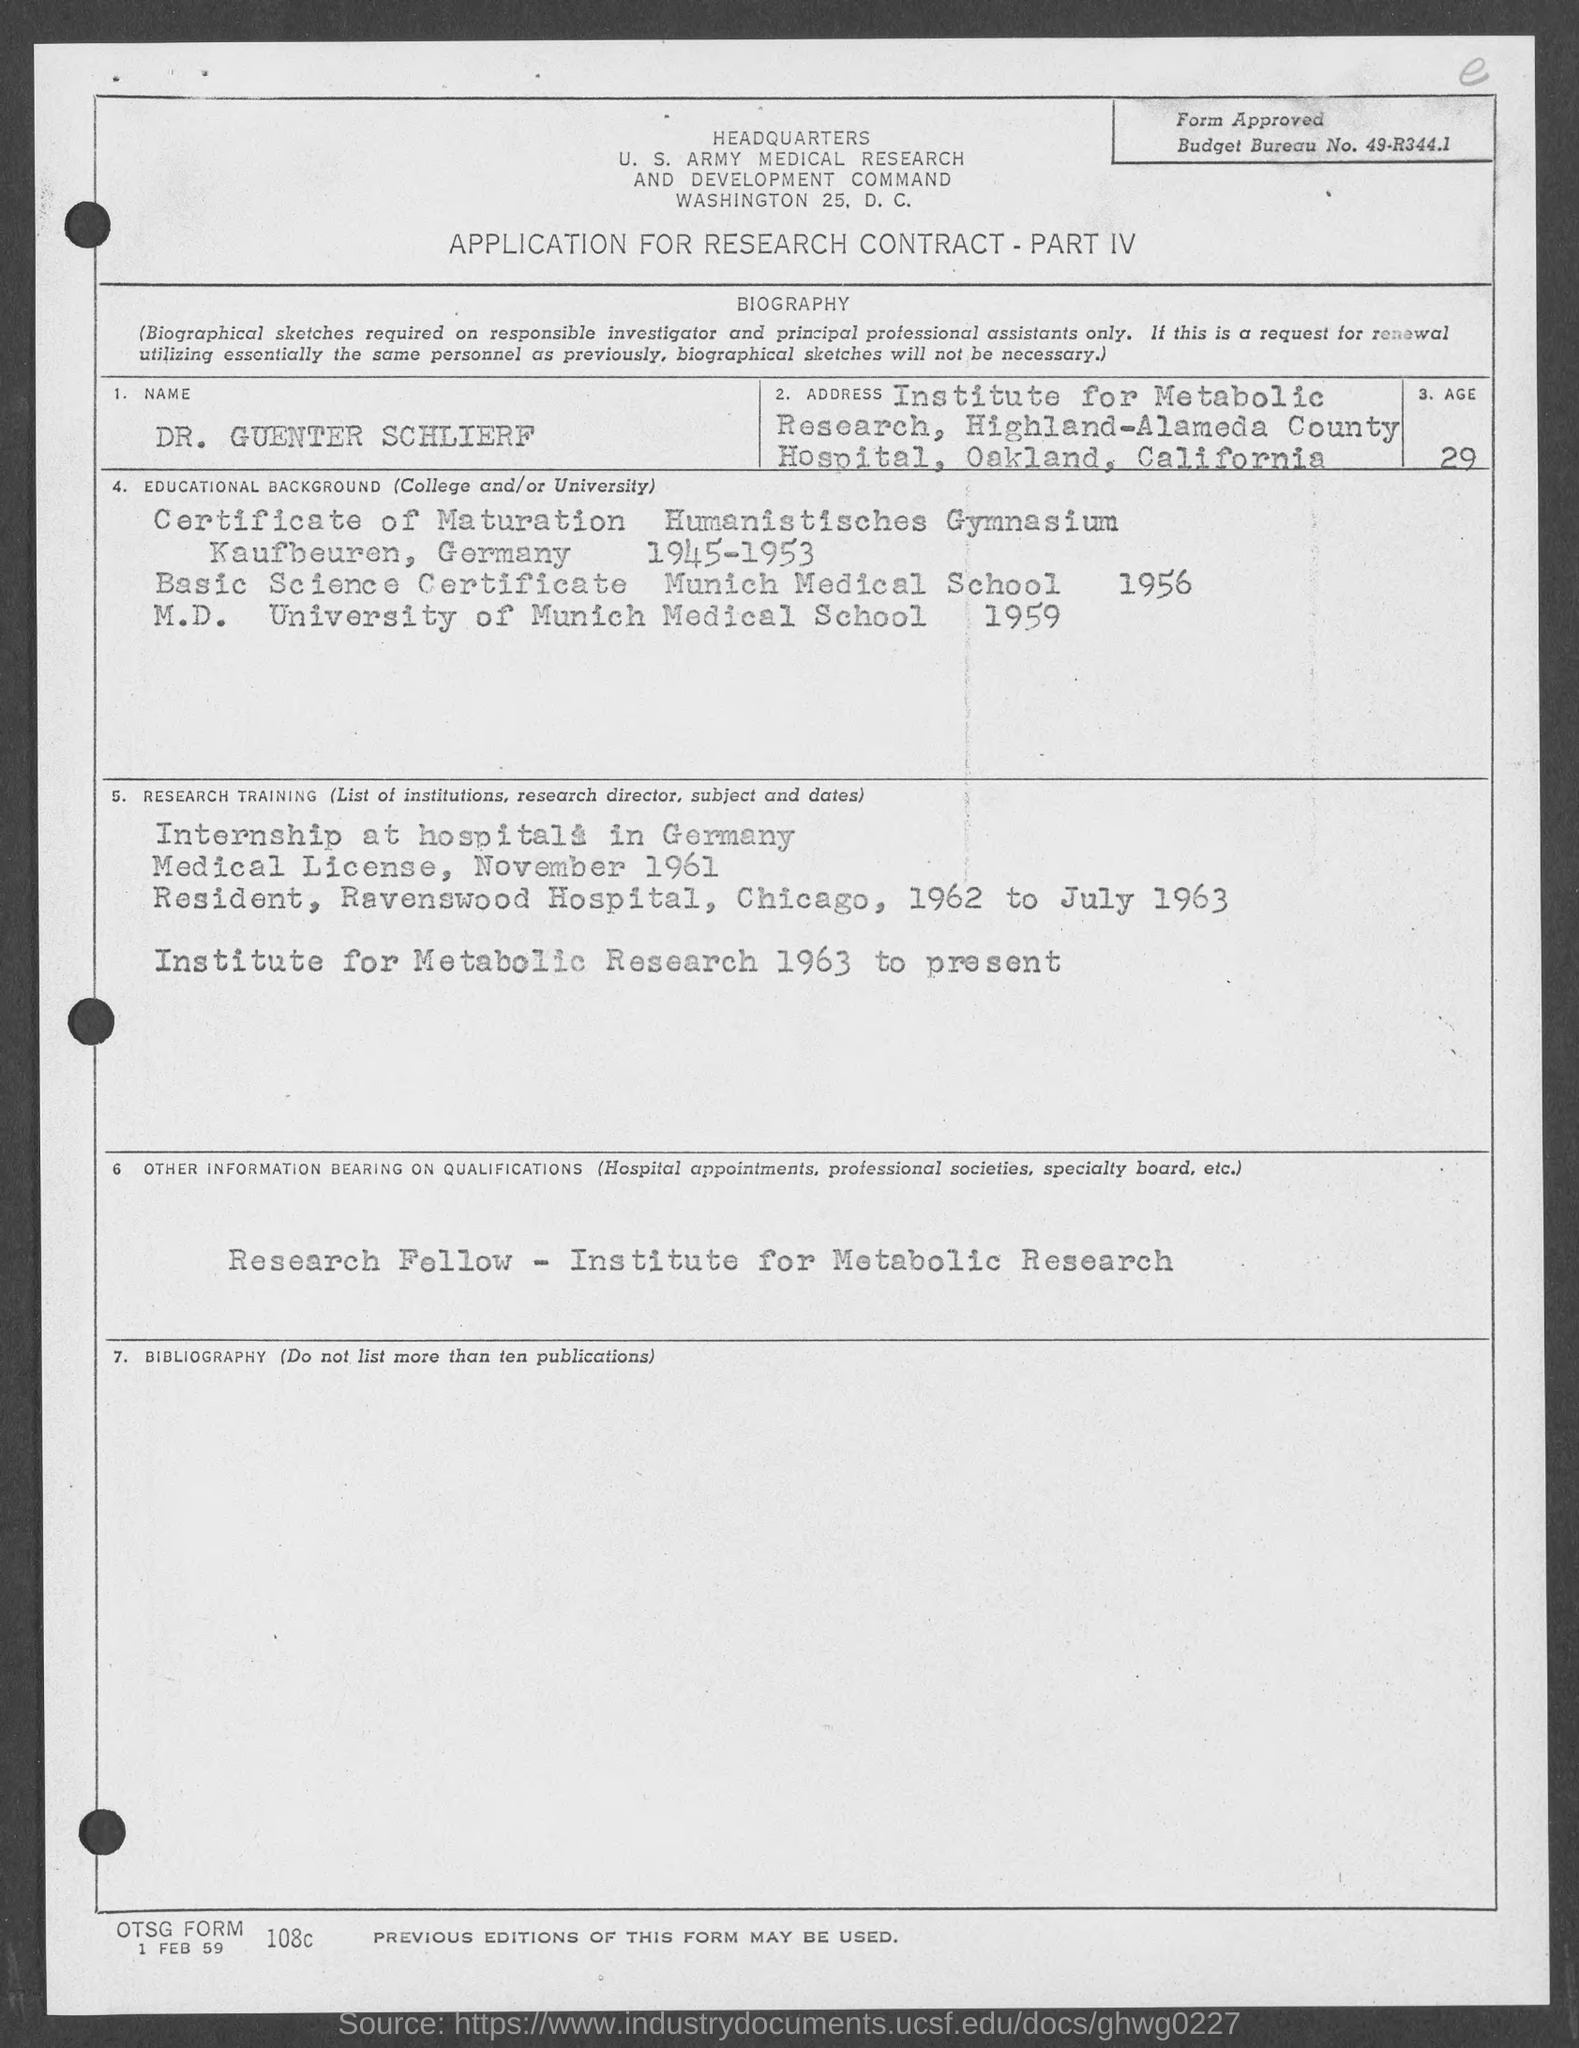What is the budget bureau no.?
Ensure brevity in your answer.  49-R344.1. What is the name of person ?
Ensure brevity in your answer.  DR. GUENTER SCHLIERF. In which city is u.s. army medical research and development command at?
Your answer should be compact. Washington 25. What is the age of person ?
Offer a very short reply. 29. In which year did candidate complete his m.d.?
Ensure brevity in your answer.  1959. In which year did candidate complete his basic science certificate ?
Your response must be concise. 1956. What is the date below otsg form?
Ensure brevity in your answer.  1 FEB 59. 